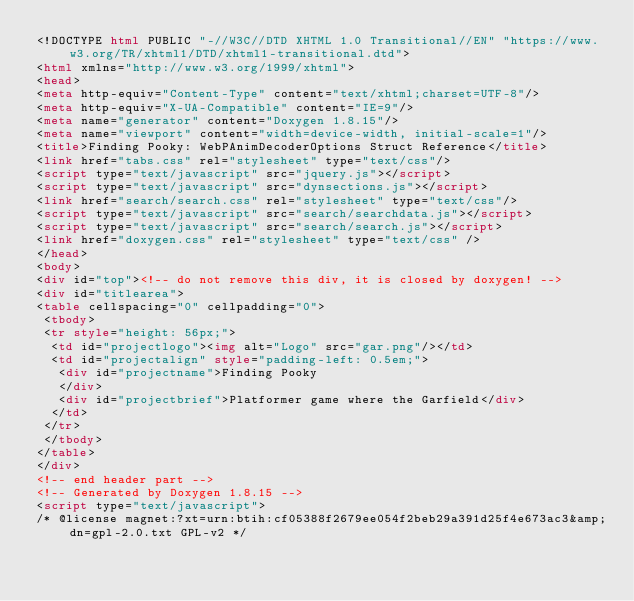Convert code to text. <code><loc_0><loc_0><loc_500><loc_500><_HTML_><!DOCTYPE html PUBLIC "-//W3C//DTD XHTML 1.0 Transitional//EN" "https://www.w3.org/TR/xhtml1/DTD/xhtml1-transitional.dtd">
<html xmlns="http://www.w3.org/1999/xhtml">
<head>
<meta http-equiv="Content-Type" content="text/xhtml;charset=UTF-8"/>
<meta http-equiv="X-UA-Compatible" content="IE=9"/>
<meta name="generator" content="Doxygen 1.8.15"/>
<meta name="viewport" content="width=device-width, initial-scale=1"/>
<title>Finding Pooky: WebPAnimDecoderOptions Struct Reference</title>
<link href="tabs.css" rel="stylesheet" type="text/css"/>
<script type="text/javascript" src="jquery.js"></script>
<script type="text/javascript" src="dynsections.js"></script>
<link href="search/search.css" rel="stylesheet" type="text/css"/>
<script type="text/javascript" src="search/searchdata.js"></script>
<script type="text/javascript" src="search/search.js"></script>
<link href="doxygen.css" rel="stylesheet" type="text/css" />
</head>
<body>
<div id="top"><!-- do not remove this div, it is closed by doxygen! -->
<div id="titlearea">
<table cellspacing="0" cellpadding="0">
 <tbody>
 <tr style="height: 56px;">
  <td id="projectlogo"><img alt="Logo" src="gar.png"/></td>
  <td id="projectalign" style="padding-left: 0.5em;">
   <div id="projectname">Finding Pooky
   </div>
   <div id="projectbrief">Platformer game where the Garfield</div>
  </td>
 </tr>
 </tbody>
</table>
</div>
<!-- end header part -->
<!-- Generated by Doxygen 1.8.15 -->
<script type="text/javascript">
/* @license magnet:?xt=urn:btih:cf05388f2679ee054f2beb29a391d25f4e673ac3&amp;dn=gpl-2.0.txt GPL-v2 */</code> 